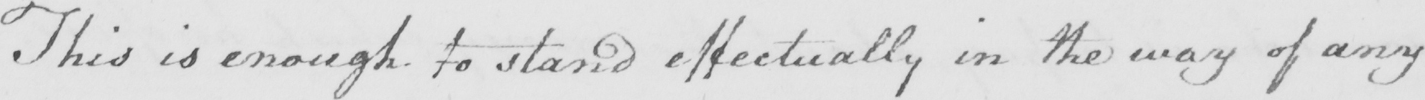Can you tell me what this handwritten text says? This is enough to stand effectually in the way of any 